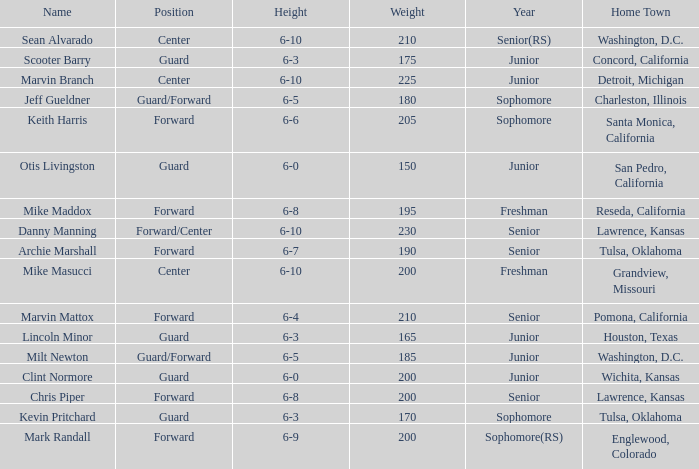Can you inform me of the name with a 6-5 stature and in their junior year? Milt Newton. 